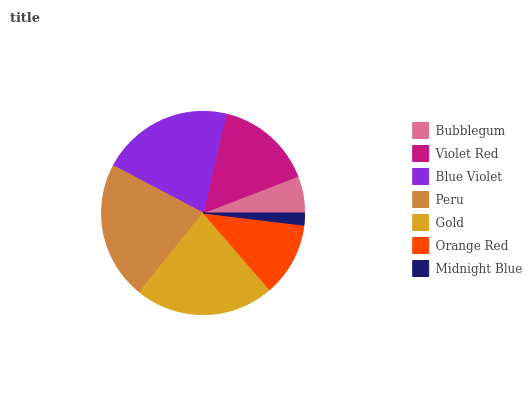Is Midnight Blue the minimum?
Answer yes or no. Yes. Is Gold the maximum?
Answer yes or no. Yes. Is Violet Red the minimum?
Answer yes or no. No. Is Violet Red the maximum?
Answer yes or no. No. Is Violet Red greater than Bubblegum?
Answer yes or no. Yes. Is Bubblegum less than Violet Red?
Answer yes or no. Yes. Is Bubblegum greater than Violet Red?
Answer yes or no. No. Is Violet Red less than Bubblegum?
Answer yes or no. No. Is Violet Red the high median?
Answer yes or no. Yes. Is Violet Red the low median?
Answer yes or no. Yes. Is Blue Violet the high median?
Answer yes or no. No. Is Bubblegum the low median?
Answer yes or no. No. 